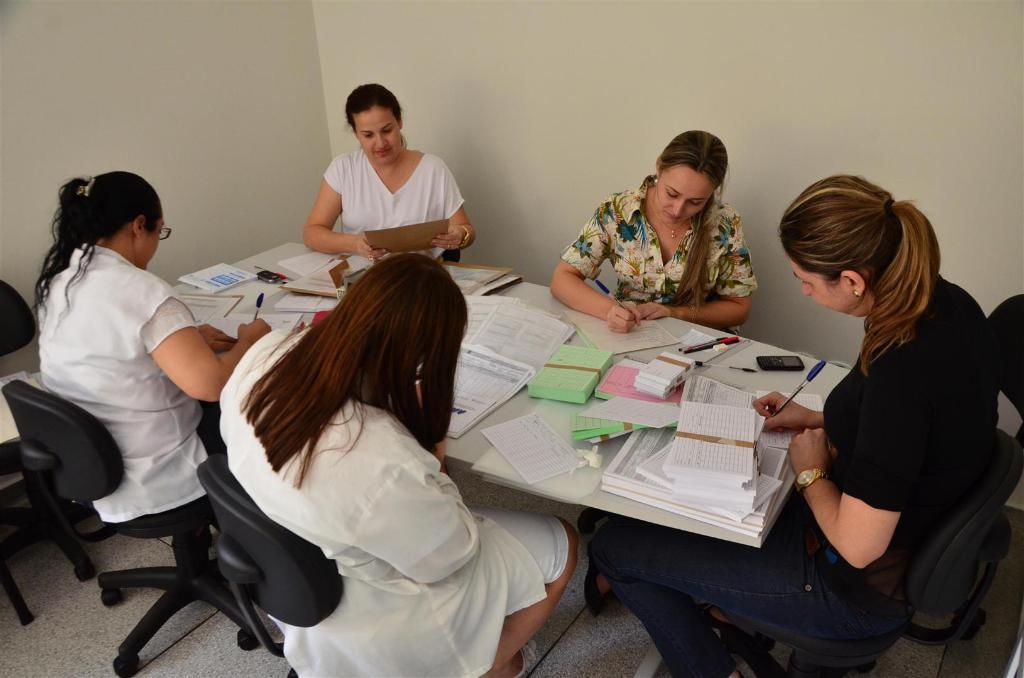How many ladies are present in the image? There are five ladies in the image. What are the ladies doing in the image? The ladies are sitting on chairs. What can be seen in front of the chairs? The chairs are in front of tables. What items are on the tables? There are papers, books, and pens on the tables. What type of land can be seen in the background of the image? There is no land visible in the image; it only shows the ladies, chairs, and tables. 